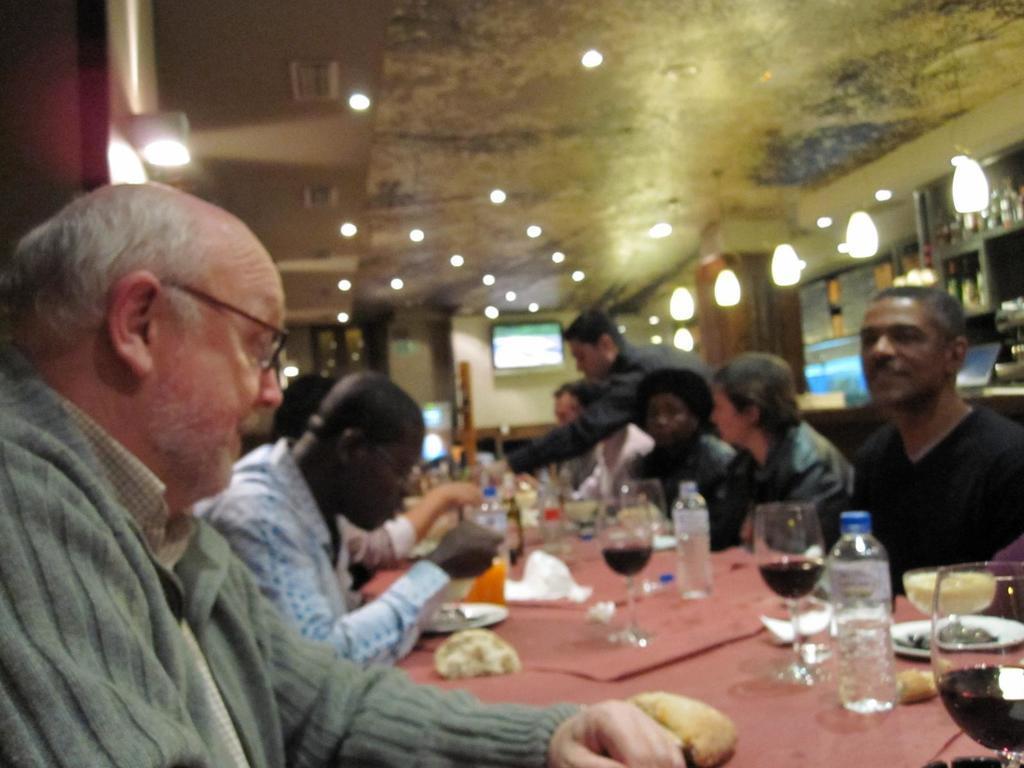In one or two sentences, can you explain what this image depicts? In this image, we can see people sitting on the chairs and some are holding some objects and one of them is standing and we can see bottles, food items, plates and there are glasses with drink and some other objects on the table. In the background, there are lights, screens and we can see some other objects. At the top, there is a roof. 